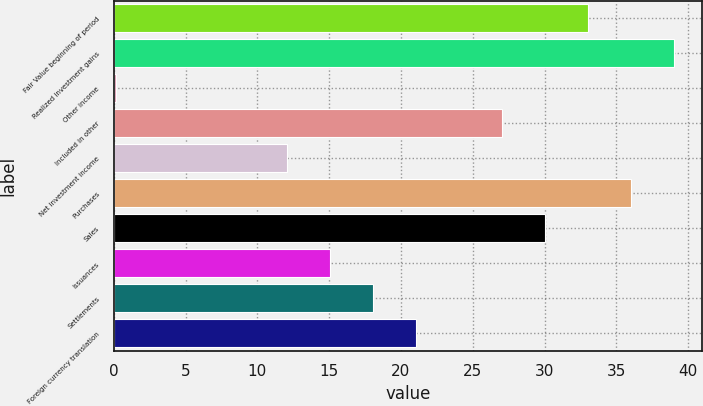<chart> <loc_0><loc_0><loc_500><loc_500><bar_chart><fcel>Fair Value beginning of period<fcel>Realized investment gains<fcel>Other income<fcel>Included in other<fcel>Net investment income<fcel>Purchases<fcel>Sales<fcel>Issuances<fcel>Settlements<fcel>Foreign currency translation<nl><fcel>33.02<fcel>39<fcel>0.13<fcel>27.04<fcel>12.09<fcel>36.01<fcel>30.03<fcel>15.08<fcel>18.07<fcel>21.06<nl></chart> 